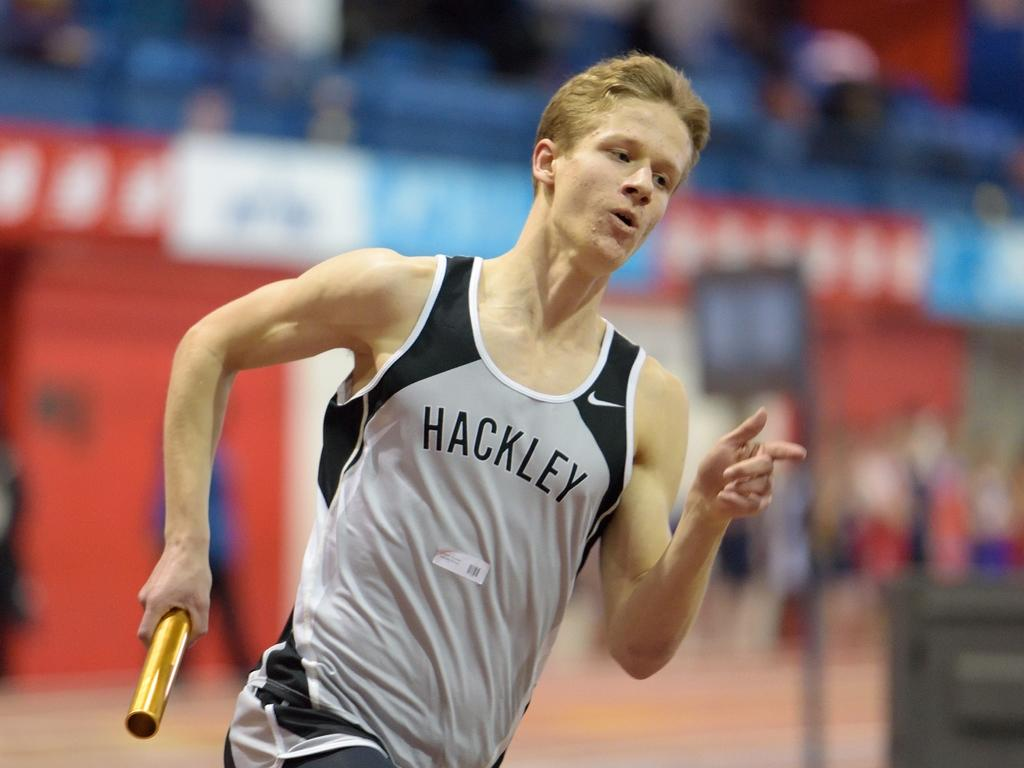<image>
Give a short and clear explanation of the subsequent image. A man wearing a Hackley jersey runs with a baton. 